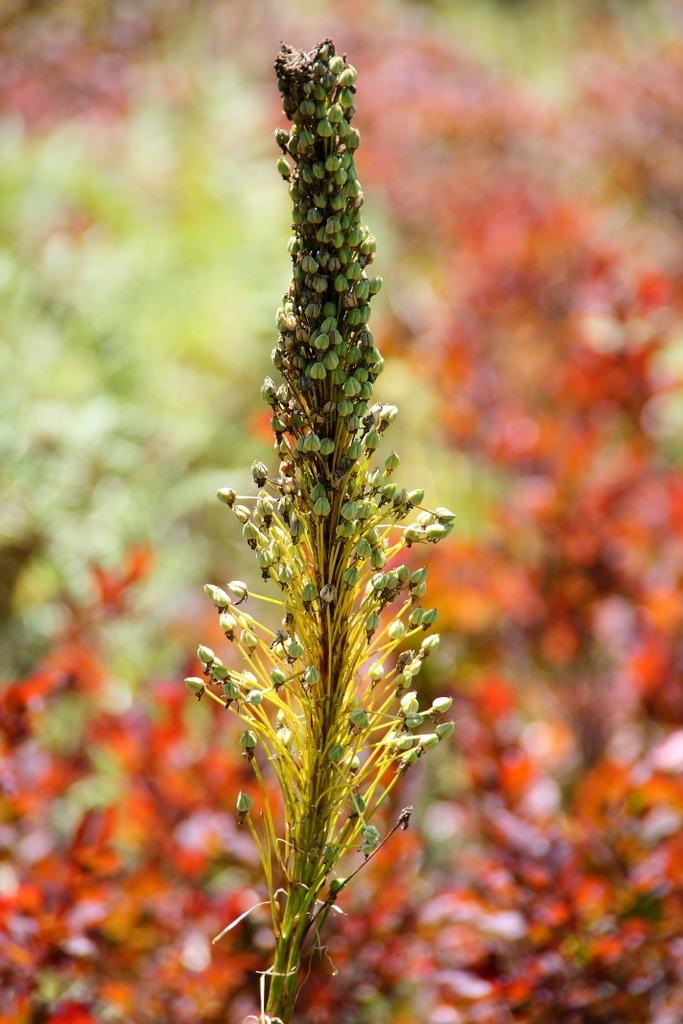What is the main subject of the image? There is a plant in the image. What can be observed on the plant? The plant has flowers or buds. What is the color of the flowers or buds? The flowers or buds are in green color. How would you describe the background of the image? The background of the image is in green and red color, and it is blurred. Can you tell me how many birds are in the flock flying over the plant in the image? There are no birds or flocks present in the image; it features a plant with flowers or buds and a blurred background. 